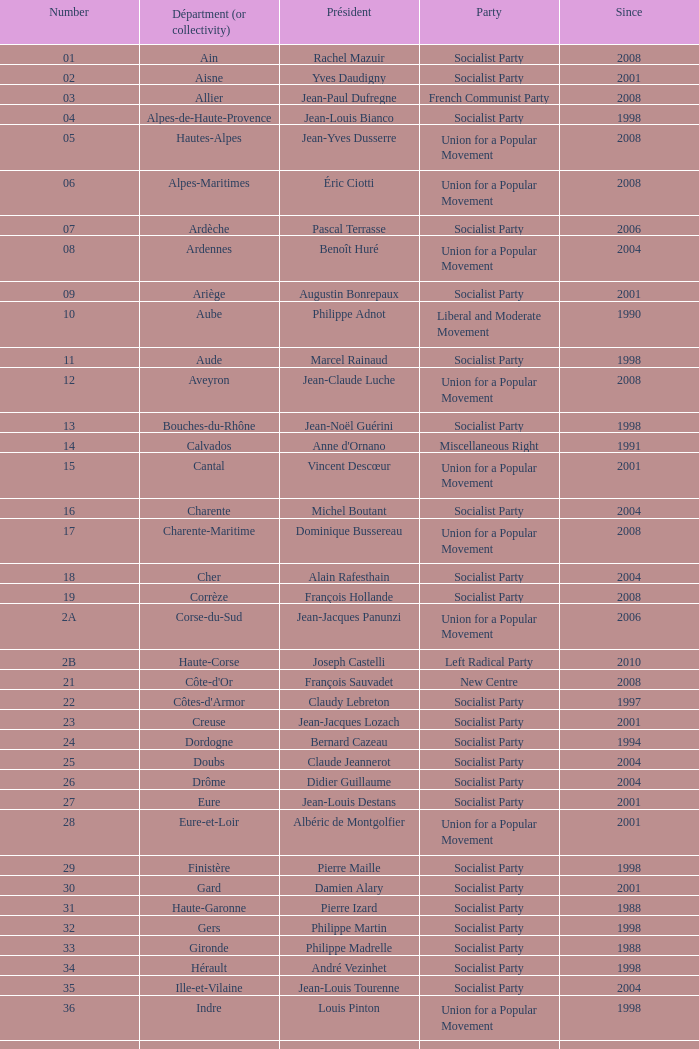Who is the president representing the Creuse department? Jean-Jacques Lozach. 